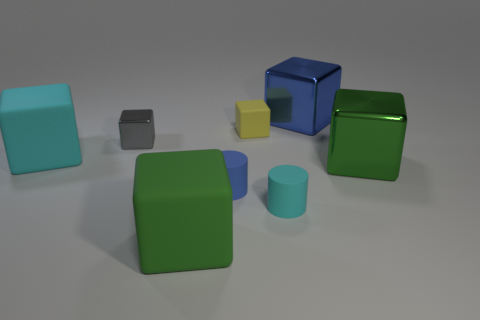Subtract all cyan matte blocks. How many blocks are left? 5 Subtract 1 cylinders. How many cylinders are left? 1 Add 2 gray shiny spheres. How many objects exist? 10 Subtract all cyan cylinders. How many cylinders are left? 1 Subtract all brown balls. How many blue blocks are left? 1 Subtract all yellow metallic objects. Subtract all gray shiny things. How many objects are left? 7 Add 7 tiny cylinders. How many tiny cylinders are left? 9 Add 5 large blocks. How many large blocks exist? 9 Subtract 0 red cubes. How many objects are left? 8 Subtract all cylinders. How many objects are left? 6 